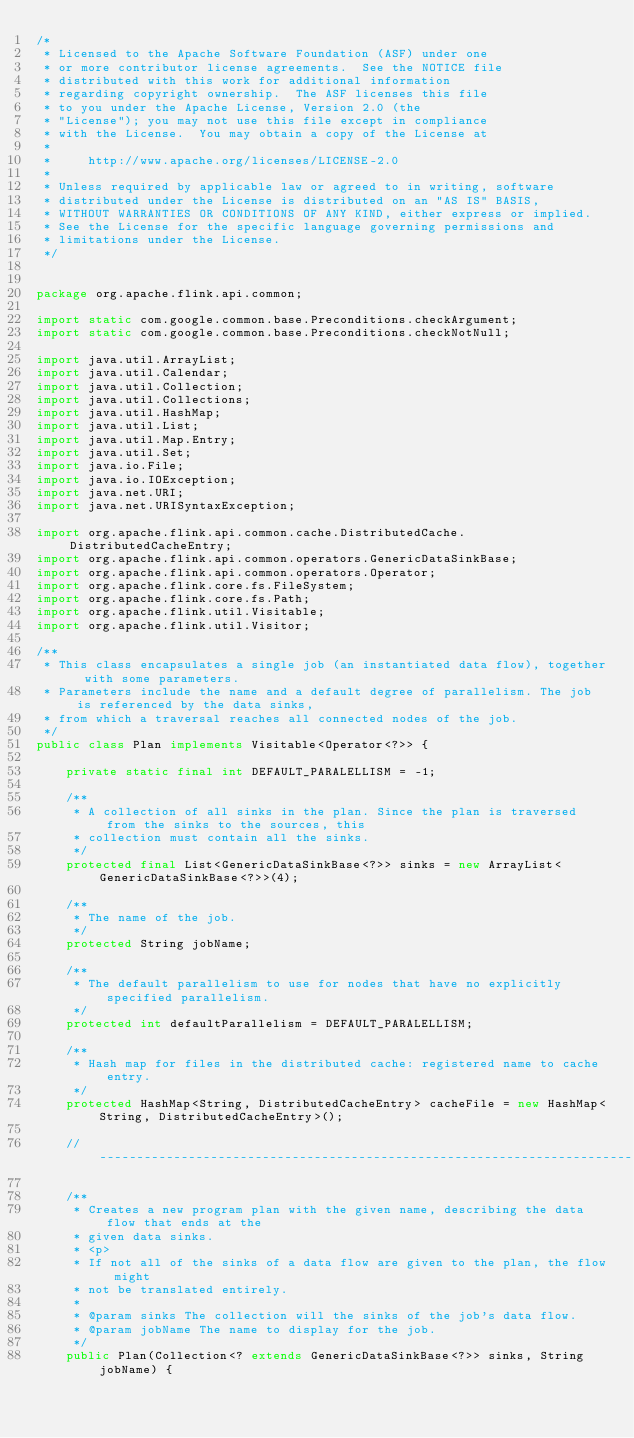<code> <loc_0><loc_0><loc_500><loc_500><_Java_>/*
 * Licensed to the Apache Software Foundation (ASF) under one
 * or more contributor license agreements.  See the NOTICE file
 * distributed with this work for additional information
 * regarding copyright ownership.  The ASF licenses this file
 * to you under the Apache License, Version 2.0 (the
 * "License"); you may not use this file except in compliance
 * with the License.  You may obtain a copy of the License at
 *
 *     http://www.apache.org/licenses/LICENSE-2.0
 *
 * Unless required by applicable law or agreed to in writing, software
 * distributed under the License is distributed on an "AS IS" BASIS,
 * WITHOUT WARRANTIES OR CONDITIONS OF ANY KIND, either express or implied.
 * See the License for the specific language governing permissions and
 * limitations under the License.
 */


package org.apache.flink.api.common;

import static com.google.common.base.Preconditions.checkArgument;
import static com.google.common.base.Preconditions.checkNotNull;

import java.util.ArrayList;
import java.util.Calendar;
import java.util.Collection;
import java.util.Collections;
import java.util.HashMap;
import java.util.List;
import java.util.Map.Entry;
import java.util.Set;
import java.io.File;
import java.io.IOException;
import java.net.URI;
import java.net.URISyntaxException;

import org.apache.flink.api.common.cache.DistributedCache.DistributedCacheEntry;
import org.apache.flink.api.common.operators.GenericDataSinkBase;
import org.apache.flink.api.common.operators.Operator;
import org.apache.flink.core.fs.FileSystem;
import org.apache.flink.core.fs.Path;
import org.apache.flink.util.Visitable;
import org.apache.flink.util.Visitor;

/**
 * This class encapsulates a single job (an instantiated data flow), together with some parameters.
 * Parameters include the name and a default degree of parallelism. The job is referenced by the data sinks,
 * from which a traversal reaches all connected nodes of the job.
 */
public class Plan implements Visitable<Operator<?>> {

	private static final int DEFAULT_PARALELLISM = -1;
	
	/**
	 * A collection of all sinks in the plan. Since the plan is traversed from the sinks to the sources, this
	 * collection must contain all the sinks.
	 */
	protected final List<GenericDataSinkBase<?>> sinks = new ArrayList<GenericDataSinkBase<?>>(4);

	/**
	 * The name of the job.
	 */
	protected String jobName;

	/**
	 * The default parallelism to use for nodes that have no explicitly specified parallelism.
	 */
	protected int defaultParallelism = DEFAULT_PARALELLISM;

	/**
	 * Hash map for files in the distributed cache: registered name to cache entry.
	 */
	protected HashMap<String, DistributedCacheEntry> cacheFile = new HashMap<String, DistributedCacheEntry>();

	// ------------------------------------------------------------------------

	/**
	 * Creates a new program plan with the given name, describing the data flow that ends at the
	 * given data sinks.
	 * <p>
	 * If not all of the sinks of a data flow are given to the plan, the flow might
	 * not be translated entirely. 
	 *  
	 * @param sinks The collection will the sinks of the job's data flow.
	 * @param jobName The name to display for the job.
	 */
	public Plan(Collection<? extends GenericDataSinkBase<?>> sinks, String jobName) {</code> 